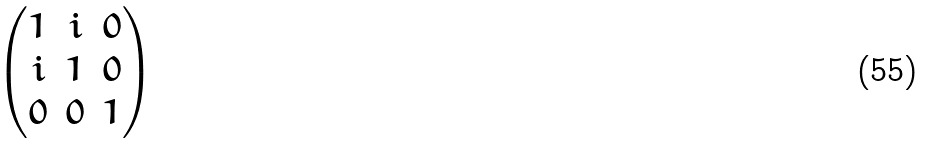<formula> <loc_0><loc_0><loc_500><loc_500>\begin{pmatrix} 1 & i & 0 \\ i & 1 & 0 \\ 0 & 0 & 1 \end{pmatrix}</formula> 